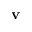<formula> <loc_0><loc_0><loc_500><loc_500>v</formula> 